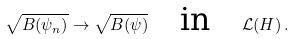<formula> <loc_0><loc_0><loc_500><loc_500>\sqrt { B ( \psi _ { n } ) } \rightarrow \sqrt { B ( \psi ) } \quad \text {in} \quad \mathcal { L } ( H ) \, .</formula> 